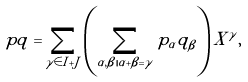<formula> <loc_0><loc_0><loc_500><loc_500>p q = \sum _ { \gamma \in I + J } \left ( \sum _ { \alpha , \beta | \alpha + \beta = \gamma } p _ { \alpha } q _ { \beta } \right ) X ^ { \gamma } ,</formula> 